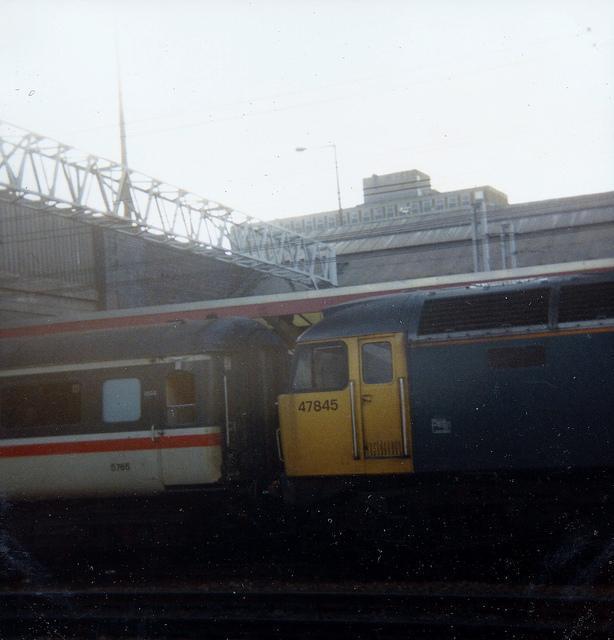How many train cars are there?
Give a very brief answer. 2. How many trains are crossing the bridge?
Give a very brief answer. 1. How many trains are blue?
Give a very brief answer. 1. How many trains are visible?
Give a very brief answer. 2. 